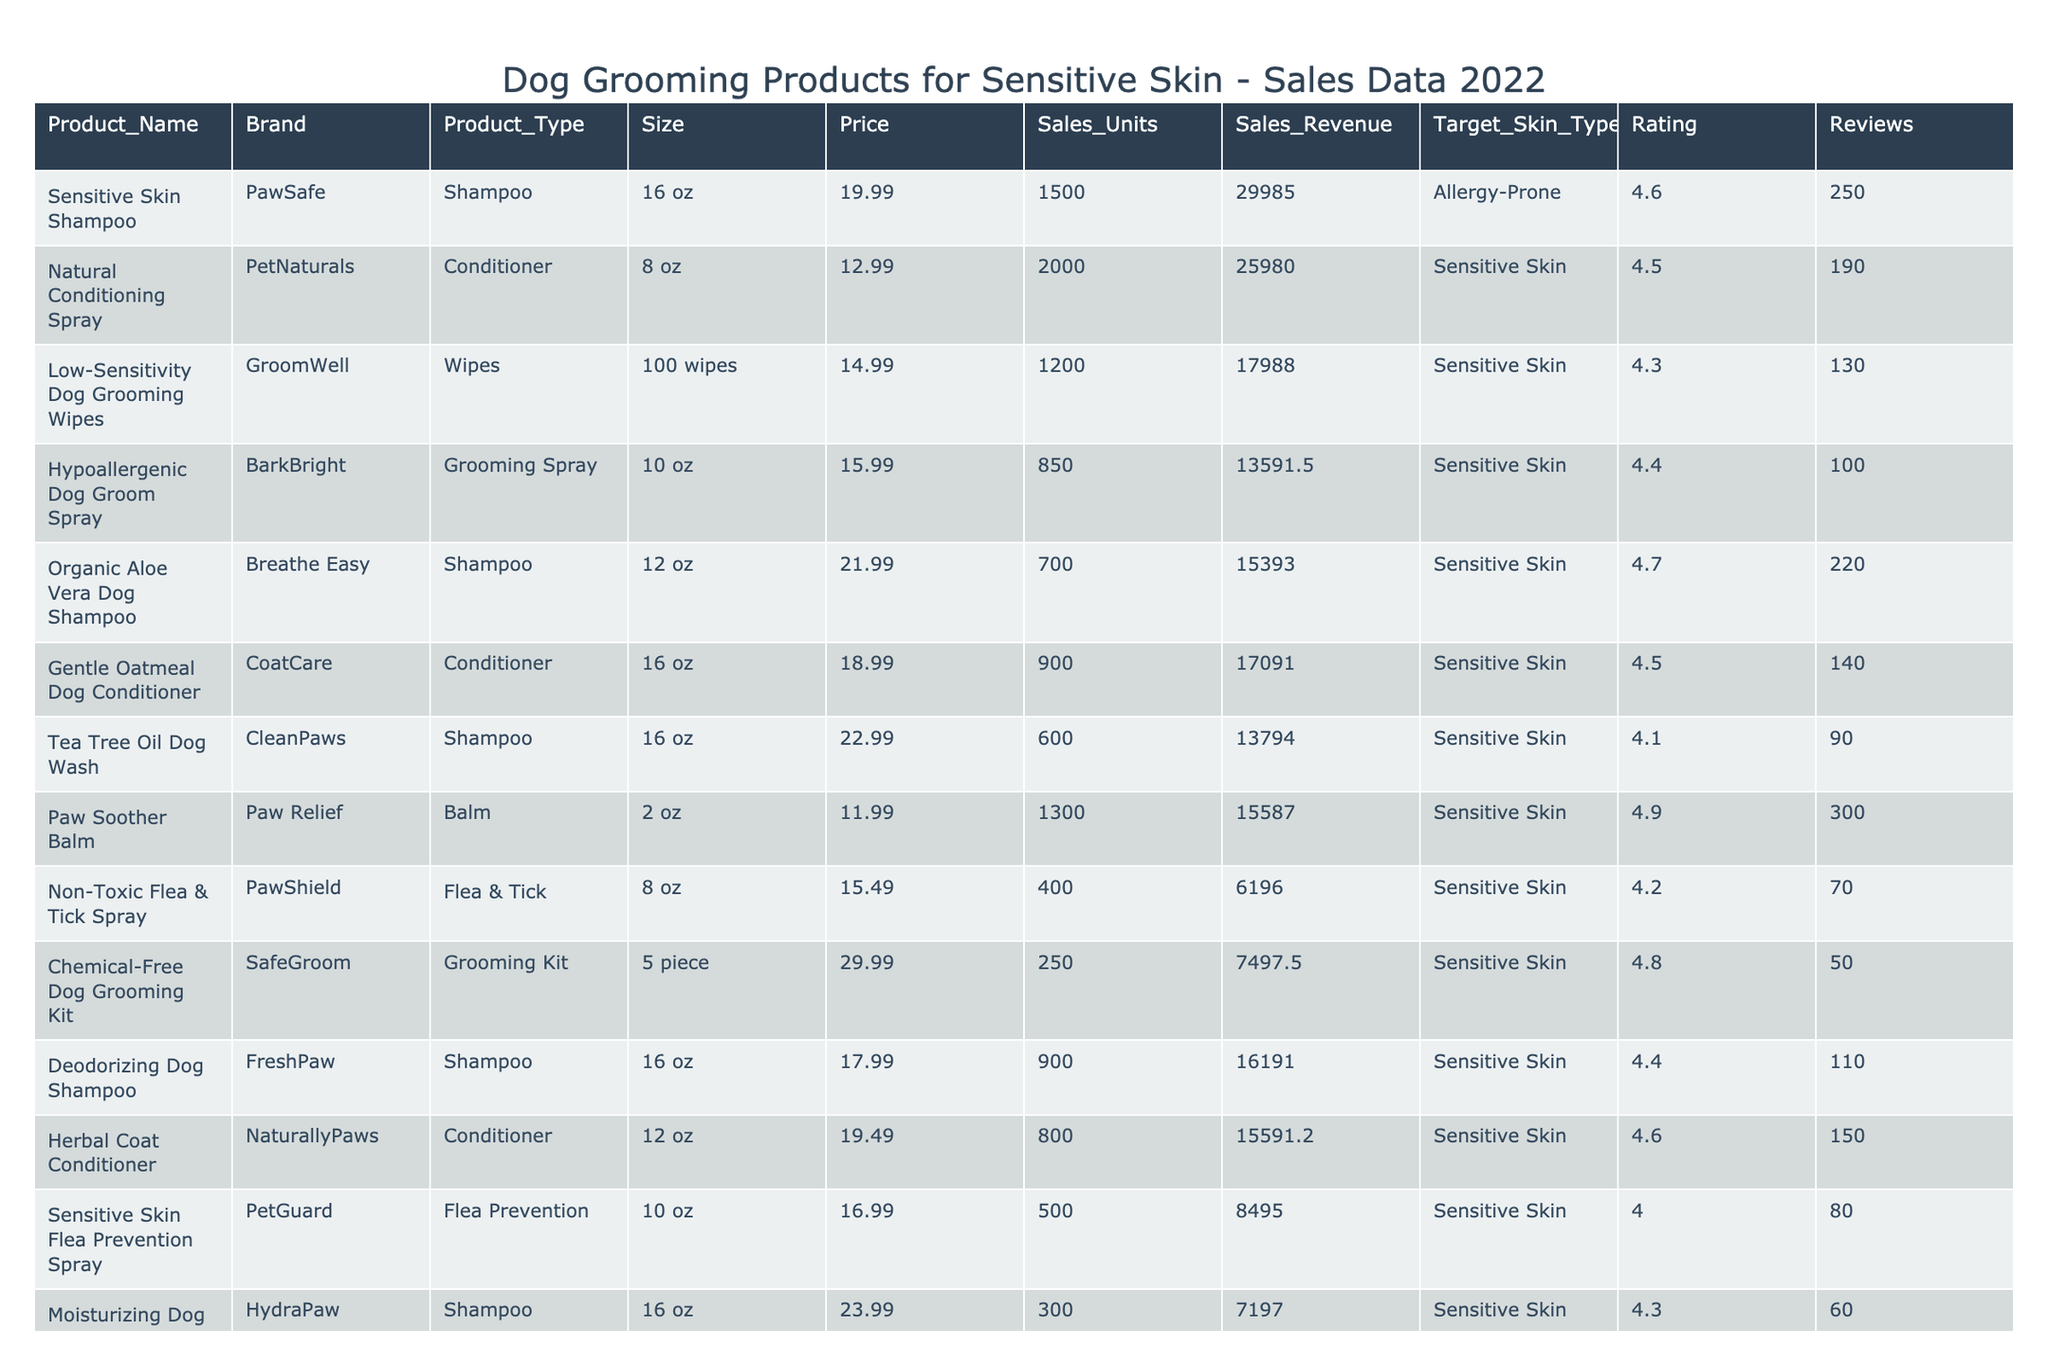What is the price of the "Organic Aloe Vera Dog Shampoo"? Looking at the table, the price for "Organic Aloe Vera Dog Shampoo" is listed directly in the Price column next to the product name. The price is $21.99.
Answer: $21.99 Which product has the highest sales revenue? By reviewing the Sales Revenue column, we see that "Sensitive Skin Shampoo" has a sales revenue of $29,985, which is higher than all other products listed.
Answer: "Sensitive Skin Shampoo" How many units of "Gentle Oatmeal Dog Conditioner" were sold? The number of units sold for "Gentle Oatmeal Dog Conditioner" is stated in the Sales Units column, which shows a figure of 900.
Answer: 900 What is the average rating of all the products for sensitive skin? To find the average rating, I will sum all the ratings of the products (4.6 + 4.5 + 4.3 + 4.4 + 4.7 + 4.5 + 4.1 + 4.9 + 4.2 + 4.8 + 4.4 + 4.6 + 4.0 + 4.3 + 4.8) = 67.5, and since there are 15 products, the average is 67.5 / 15 = 4.5.
Answer: 4.5 Is "Paw Soother Balm" more expensive than "Low-Sensitivity Dog Grooming Wipes"? The price of "Paw Soother Balm" is $11.99, while "Low-Sensitivity Dog Grooming Wipes" is priced at $14.99. Comparing the two prices shows that Paw Soother Balm is less expensive.
Answer: No What is the total sales revenue generated from all products under sensitive skin? To find the total sales revenue, I sum up all the sales revenues from the Sales Revenue column: (29985 + 25980 + 17988 + 13591.5 + 15393 + 17091 + 13794 + 15587 + 6196 + 7497.5 + 16191 + 15591.2 + 8495 + 7197 + 13491) = 146,263.2.
Answer: $146,263.2 Which product has the highest number of reviews? Checking the Reviews column, "Paw Soother Balm" has 300 reviews, which is the highest among all products listed.
Answer: "Paw Soother Balm" How does the price of "Non-Toxic Flea & Tick Spray" compare to the price of "Chemical-Free Dog Grooming Kit"? The price for "Non-Toxic Flea & Tick Spray" is $15.49 and for "Chemical-Free Dog Grooming Kit" is $29.99. Comparing these two shows that the flea spray is less expensive than the grooming kit.
Answer: Less expensive What is the total number of units sold for shampoos? The units sold for shampoos are: 1500 (Sensitive Skin Shampoo) + 700 (Organic Aloe Vera Dog Shampoo) + 600 (Tea Tree Oil Dog Wash) + 900 (Deodorizing Dog Shampoo) + 300 (Moisturizing Dog Shampoo) = 4006.
Answer: 4006 Are there any products with a rating lower than 4.0? By checking the Rating column, only "Sensitive Skin Flea Prevention Spray" has a rating of 4.0, and no other product has a rating lower than that. Therefore, there are no products with ratings below 4.0.
Answer: No 